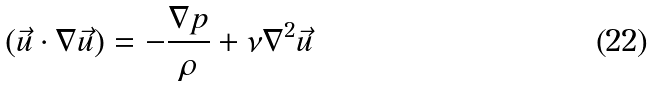<formula> <loc_0><loc_0><loc_500><loc_500>( \vec { u } \cdot \nabla \vec { u } ) = - \frac { \nabla p } { \rho } + \nu \nabla ^ { 2 } \vec { u }</formula> 